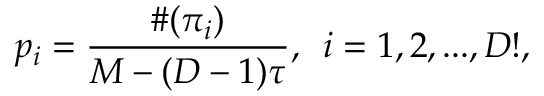Convert formula to latex. <formula><loc_0><loc_0><loc_500><loc_500>p _ { i } = \frac { \# ( \pi _ { i } ) } { M - ( D - 1 ) \tau } , \, i = 1 , 2 , \dots , D ! ,</formula> 